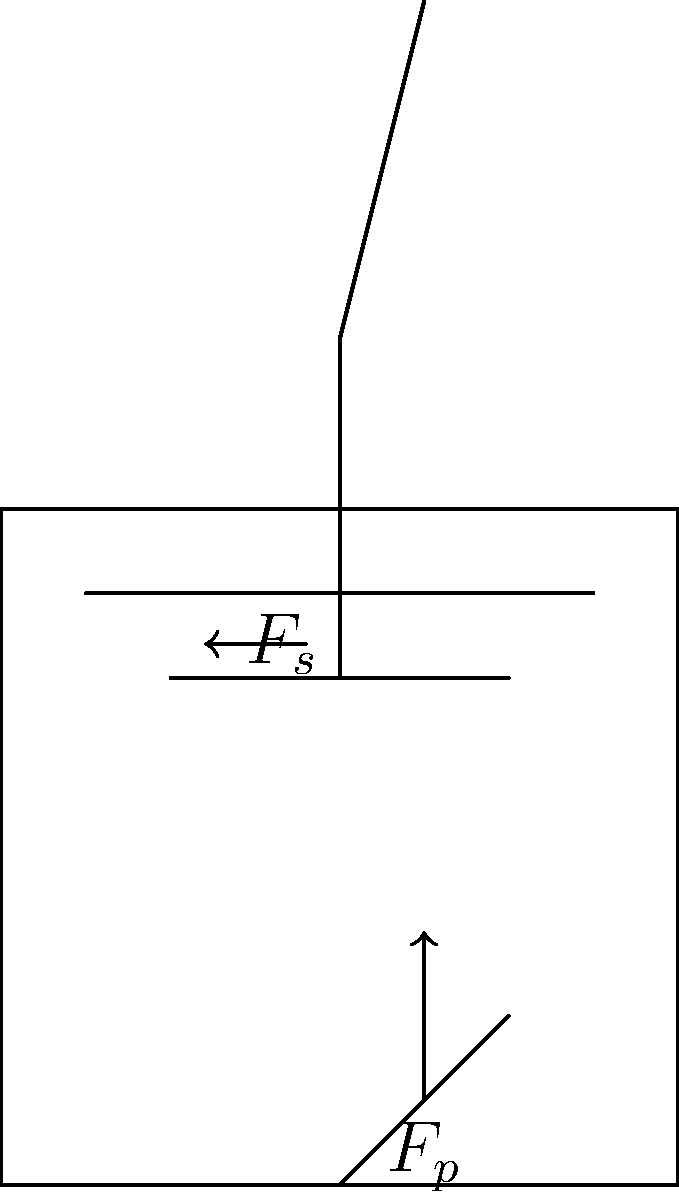In a typical cyclo, how does the rider's posture and pedal force distribution affect the overall ergonomics and efficiency of the ride? Consider the forces $F_p$ (pedal force) and $F_s$ (seat force) shown in the diagram. To understand the ergonomics and efficiency of cyclo riding, we need to consider several factors:

1. Rider's posture:
   - The diagram shows an upright posture, which is common in cyclos.
   - This posture distributes weight more evenly between the seat and handlebars.

2. Pedal force ($F_p$):
   - The upward arrow indicates the force applied by the rider's foot on the pedal.
   - In an efficient pedaling motion, this force should be applied throughout the entire pedal rotation.

3. Seat force ($F_s$):
   - The horizontal arrow represents the force exerted by the seat on the rider.
   - This force helps maintain balance and stability during riding.

4. Force distribution:
   - The upright posture allows for a more balanced distribution of forces between the pedals and seat.
   - This distribution reduces strain on any single muscle group, improving comfort for long rides.

5. Efficiency considerations:
   - The upright posture may reduce aerodynamic efficiency compared to a more forward-leaning position.
   - However, it provides better visibility in traffic, which is crucial in Cambodian cities.

6. Cultural adaptation:
   - The design of cyclos in Cambodia has evolved to suit local needs and preferences.
   - The upright posture allows for easy communication with passengers and better maneuverability in crowded streets.

In conclusion, the ergonomics of cyclo riding in Cambodia prioritize comfort, stability, and cultural appropriateness over maximum pedaling efficiency. The upright posture and balanced force distribution between pedals and seat contribute to a ride that is sustainable for long periods, which is essential for cyclo drivers in urban environments.
Answer: Upright posture balances comfort and stability, sacrificing some pedaling efficiency for cultural appropriateness and urban maneuverability. 